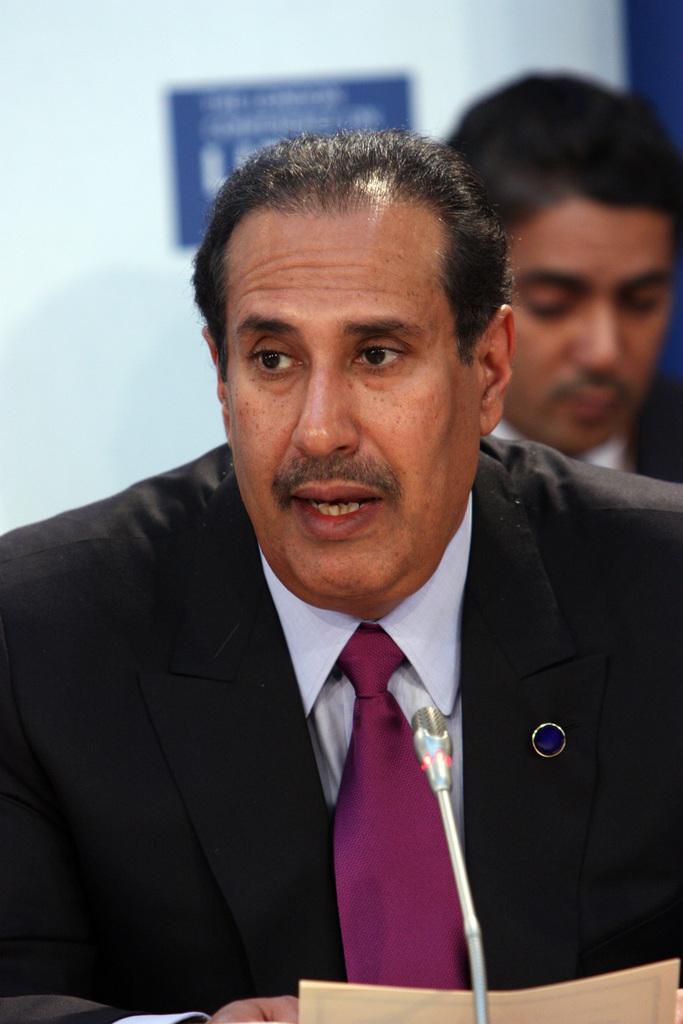In one or two sentences, can you explain what this image depicts? In this image, I can see a man, mike and a paper. Behind the man, there is a person and a poster on a white surface. 